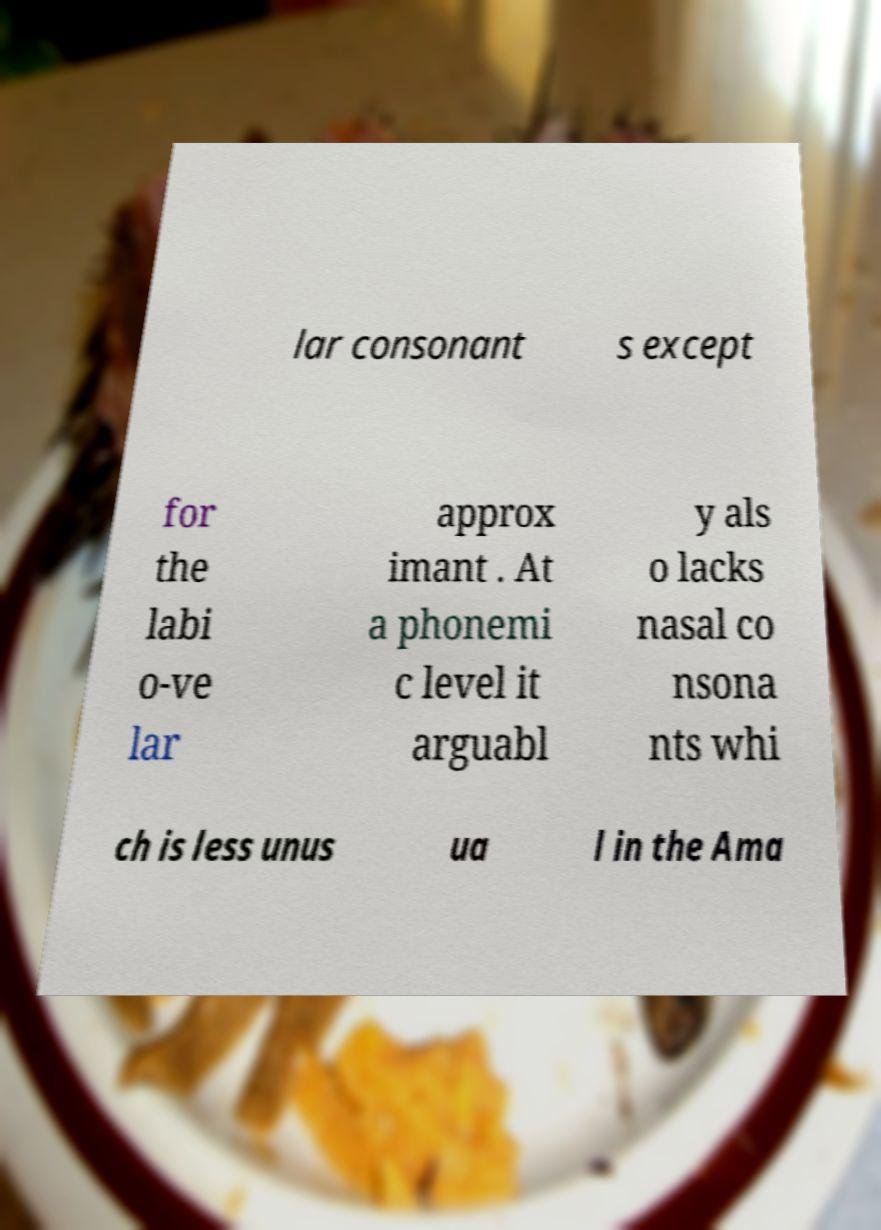Can you read and provide the text displayed in the image?This photo seems to have some interesting text. Can you extract and type it out for me? lar consonant s except for the labi o-ve lar approx imant . At a phonemi c level it arguabl y als o lacks nasal co nsona nts whi ch is less unus ua l in the Ama 